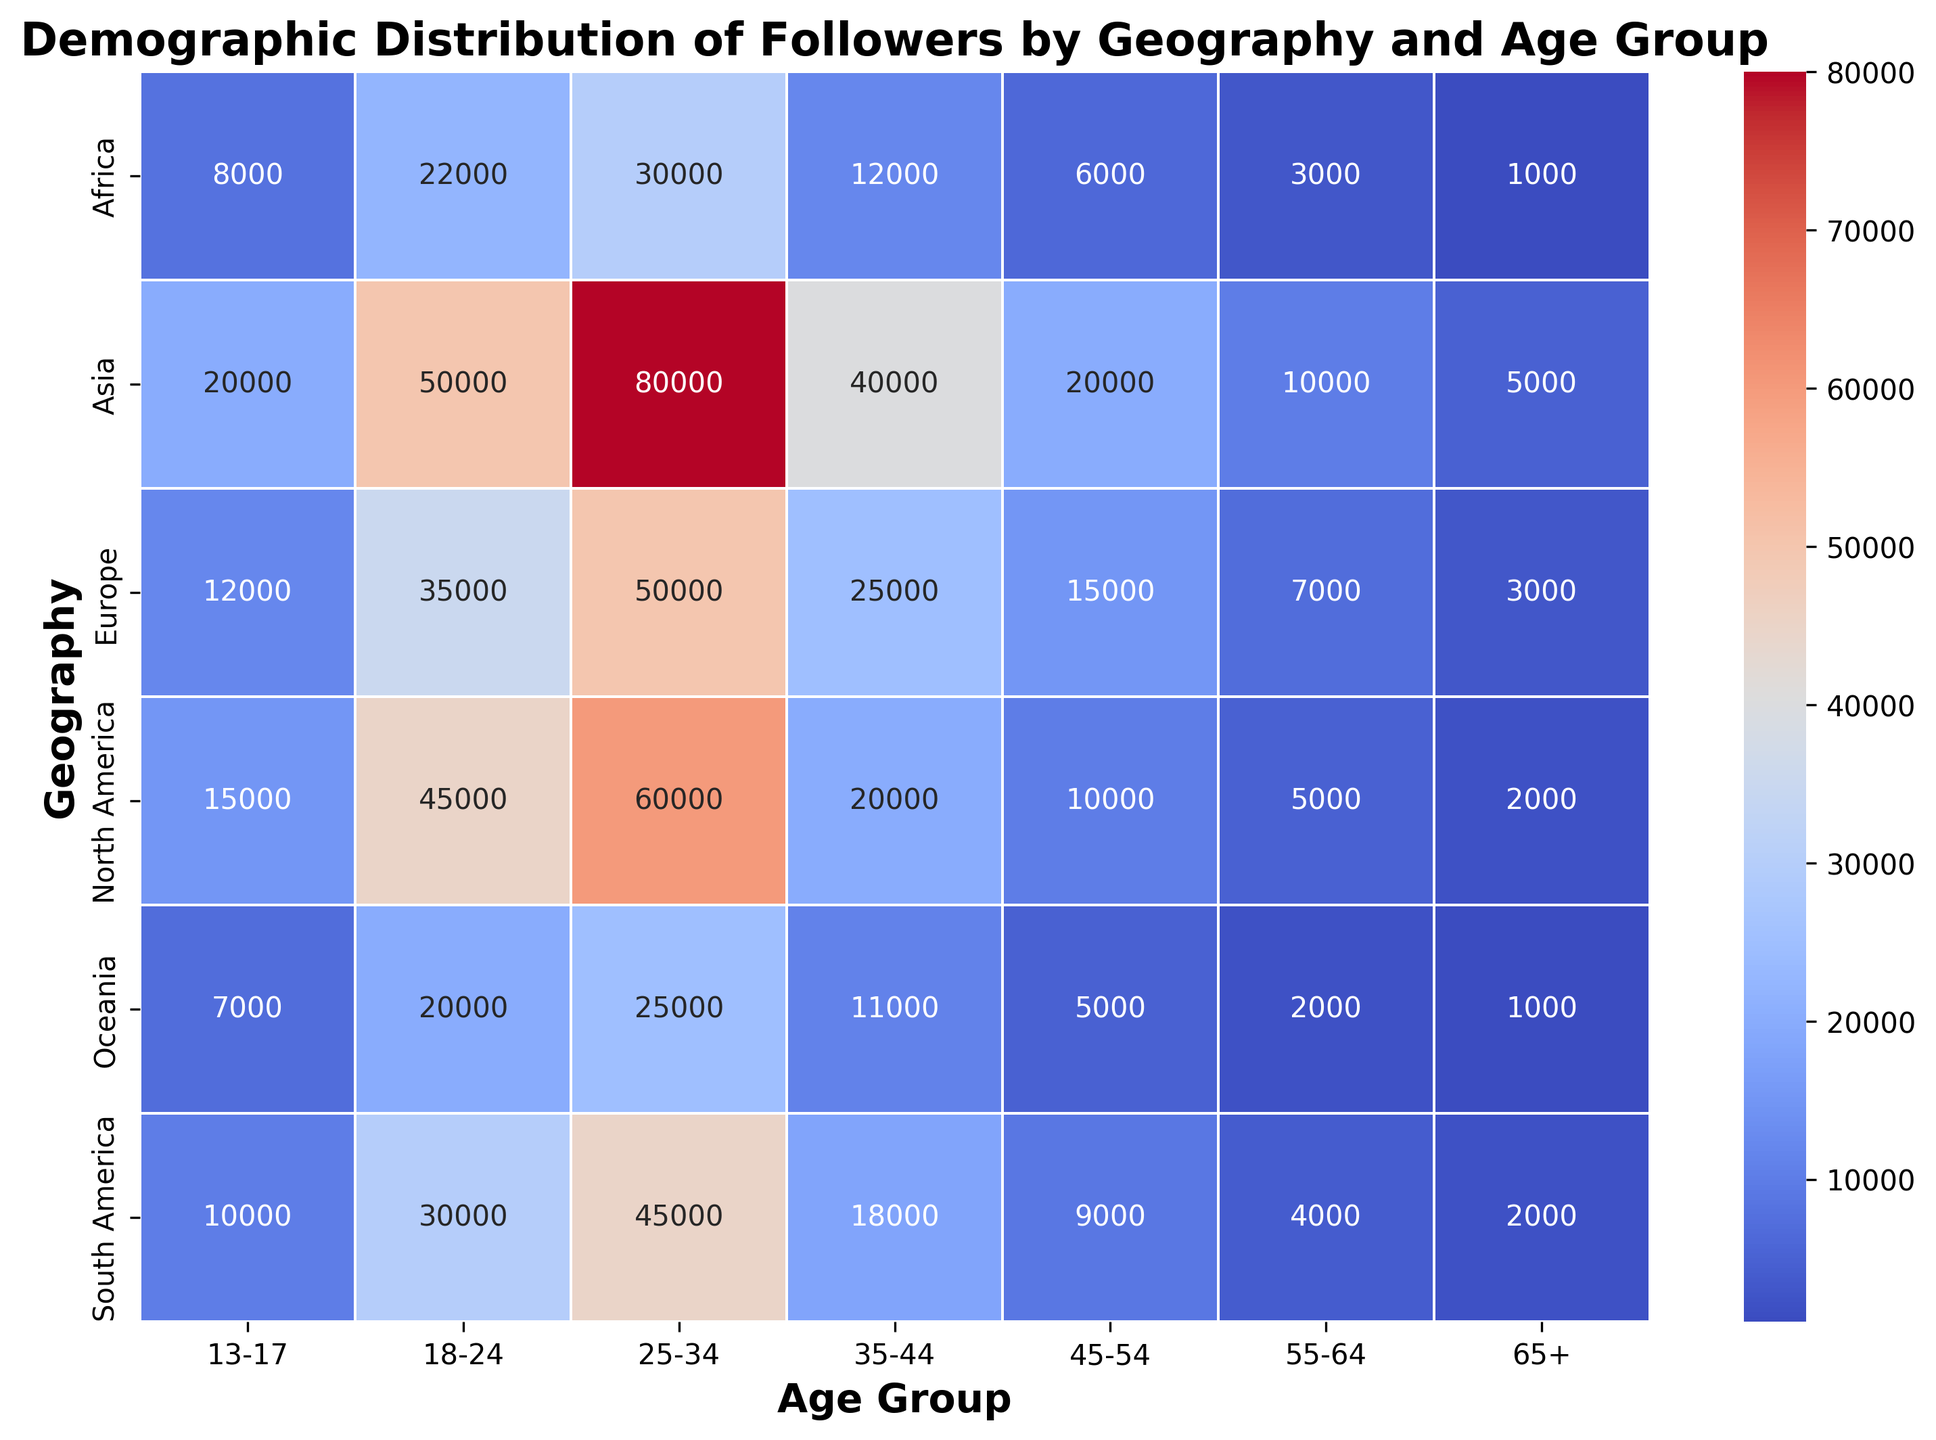What's the total number of followers for the 25-34 age group across all geographies? Sum the followers for the 25-34 age group in all geographies: 60000 (North America) + 50000 (Europe) + 80000 (Asia) + 45000 (South America) + 30000 (Africa) + 25000 (Oceania). The total is 290000.
Answer: 290000 Which age group has the highest number of followers in North America? Look at the North America row and compare the values for each age group. The highest number of followers is 60000 for the 25-34 age group.
Answer: 25-34 In which geography and age group combination is there the lowest number of followers? Scan the entire heatmap to find the lowest number, which is 1000. This occurs in both Africa and Oceania for the 65+ age group.
Answer: Africa and Oceania, 65+ Compare the number of followers in the 18-24 age group for Asia and Europe. Which has more? Look at the values for Asia and Europe in the 18-24 age group. Asia has 50000 followers, and Europe has 35000. Asia has more followers.
Answer: Asia Which age group has the most uniform distribution across all geographies? Compare the variance in followers for each age group across all geographies. The 13-17 age group has relatively similar numbers across geographies, ranging from 7000 to 20000.
Answer: 13-17 What is the average number of followers for the 35-44 age group across all geographies? Sum the followers for the 35-44 age group in all geographies and divide by the number of geographies: (20000 + 25000 + 40000 + 18000 + 12000 + 11000) / 6 = 126000 / 6 = 21000.
Answer: 21000 In which geography do the 45-54 and 55-64 age groups together account for the highest number of followers? Sum the followers for the 45-54 and 55-64 age groups in each geography and compare: 
North America: 10000 + 5000 = 15000
Europe: 15000 + 7000 = 22000
Asia: 20000 + 10000 = 30000
South America: 9000 + 4000 = 13000
Africa: 6000 + 3000 = 9000
Oceania: 5000 + 2000 = 7000
Asia has the highest combined total of 30000.
Answer: Asia Which two geographies have the most similar distribution of followers across all age groups? Compare the values across all age groups for each pair of geographies. Europe and North America have relatively similar distributions of followers across most age groups.
Answer: Europe and North America What is the difference in the number of followers between the 18-24 and 55-64 age groups in South America? Subtract the number of followers in the 55-64 age group from the 18-24 age group in South America: 30000 - 4000 = 26000.
Answer: 26000 